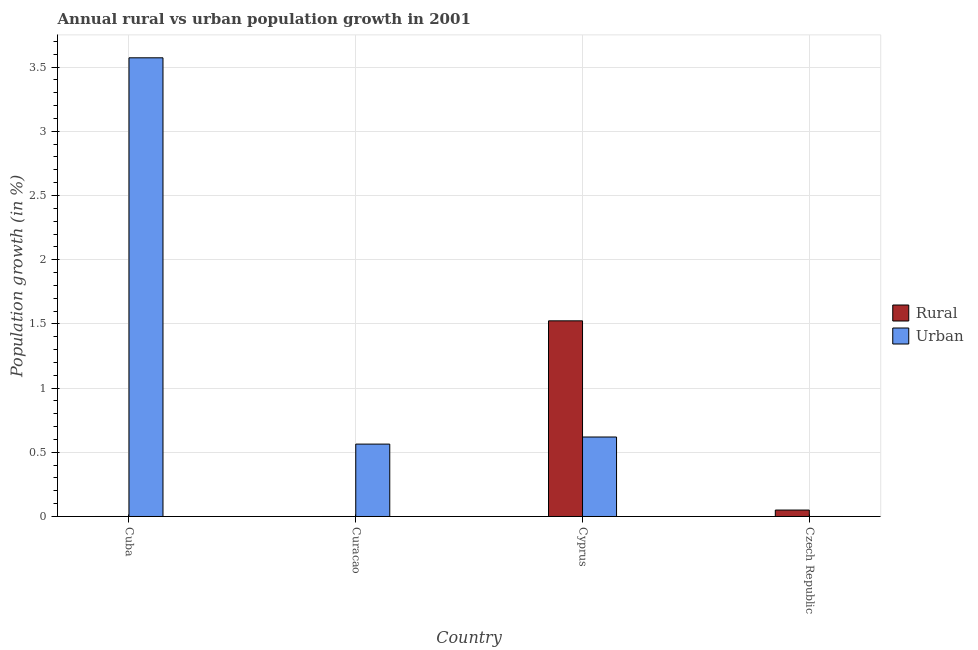How many different coloured bars are there?
Your answer should be very brief. 2. Are the number of bars per tick equal to the number of legend labels?
Offer a very short reply. No. Are the number of bars on each tick of the X-axis equal?
Your response must be concise. No. How many bars are there on the 3rd tick from the left?
Give a very brief answer. 2. What is the label of the 3rd group of bars from the left?
Offer a terse response. Cyprus. Across all countries, what is the maximum urban population growth?
Give a very brief answer. 3.57. Across all countries, what is the minimum rural population growth?
Your answer should be compact. 0. In which country was the urban population growth maximum?
Your answer should be very brief. Cuba. What is the total urban population growth in the graph?
Ensure brevity in your answer.  4.76. What is the difference between the rural population growth in Cyprus and that in Czech Republic?
Make the answer very short. 1.47. What is the difference between the rural population growth in Cuba and the urban population growth in Curacao?
Offer a very short reply. -0.56. What is the average urban population growth per country?
Give a very brief answer. 1.19. What is the difference between the urban population growth and rural population growth in Cyprus?
Ensure brevity in your answer.  -0.9. What is the ratio of the urban population growth in Cuba to that in Curacao?
Ensure brevity in your answer.  6.34. What is the difference between the highest and the second highest urban population growth?
Offer a terse response. 2.95. What is the difference between the highest and the lowest rural population growth?
Provide a short and direct response. 1.52. Is the sum of the urban population growth in Curacao and Cyprus greater than the maximum rural population growth across all countries?
Make the answer very short. No. How many bars are there?
Provide a succinct answer. 5. Are all the bars in the graph horizontal?
Your answer should be compact. No. What is the difference between two consecutive major ticks on the Y-axis?
Provide a succinct answer. 0.5. Are the values on the major ticks of Y-axis written in scientific E-notation?
Your response must be concise. No. Where does the legend appear in the graph?
Offer a very short reply. Center right. What is the title of the graph?
Make the answer very short. Annual rural vs urban population growth in 2001. Does "Mobile cellular" appear as one of the legend labels in the graph?
Keep it short and to the point. No. What is the label or title of the X-axis?
Make the answer very short. Country. What is the label or title of the Y-axis?
Provide a succinct answer. Population growth (in %). What is the Population growth (in %) of Rural in Cuba?
Your answer should be very brief. 0. What is the Population growth (in %) in Urban  in Cuba?
Make the answer very short. 3.57. What is the Population growth (in %) of Rural in Curacao?
Your answer should be very brief. 0. What is the Population growth (in %) in Urban  in Curacao?
Ensure brevity in your answer.  0.56. What is the Population growth (in %) of Rural in Cyprus?
Give a very brief answer. 1.52. What is the Population growth (in %) in Urban  in Cyprus?
Your answer should be compact. 0.62. What is the Population growth (in %) in Rural in Czech Republic?
Provide a succinct answer. 0.05. Across all countries, what is the maximum Population growth (in %) in Rural?
Provide a succinct answer. 1.52. Across all countries, what is the maximum Population growth (in %) of Urban ?
Your answer should be very brief. 3.57. Across all countries, what is the minimum Population growth (in %) of Rural?
Your answer should be very brief. 0. Across all countries, what is the minimum Population growth (in %) in Urban ?
Ensure brevity in your answer.  0. What is the total Population growth (in %) in Rural in the graph?
Keep it short and to the point. 1.57. What is the total Population growth (in %) of Urban  in the graph?
Offer a terse response. 4.76. What is the difference between the Population growth (in %) of Urban  in Cuba and that in Curacao?
Keep it short and to the point. 3.01. What is the difference between the Population growth (in %) in Urban  in Cuba and that in Cyprus?
Keep it short and to the point. 2.95. What is the difference between the Population growth (in %) in Urban  in Curacao and that in Cyprus?
Make the answer very short. -0.06. What is the difference between the Population growth (in %) of Rural in Cyprus and that in Czech Republic?
Keep it short and to the point. 1.47. What is the average Population growth (in %) of Rural per country?
Offer a very short reply. 0.39. What is the average Population growth (in %) of Urban  per country?
Offer a terse response. 1.19. What is the difference between the Population growth (in %) of Rural and Population growth (in %) of Urban  in Cyprus?
Your answer should be very brief. 0.9. What is the ratio of the Population growth (in %) in Urban  in Cuba to that in Curacao?
Give a very brief answer. 6.34. What is the ratio of the Population growth (in %) of Urban  in Cuba to that in Cyprus?
Ensure brevity in your answer.  5.77. What is the ratio of the Population growth (in %) in Urban  in Curacao to that in Cyprus?
Your answer should be very brief. 0.91. What is the ratio of the Population growth (in %) of Rural in Cyprus to that in Czech Republic?
Provide a short and direct response. 30.41. What is the difference between the highest and the second highest Population growth (in %) in Urban ?
Ensure brevity in your answer.  2.95. What is the difference between the highest and the lowest Population growth (in %) in Rural?
Your answer should be very brief. 1.52. What is the difference between the highest and the lowest Population growth (in %) in Urban ?
Your answer should be compact. 3.57. 